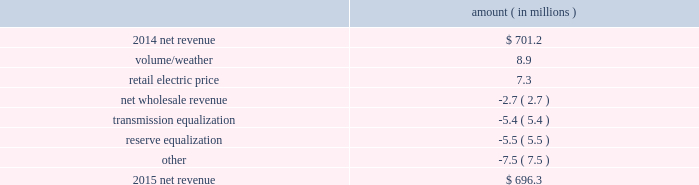Entergy mississippi , inc .
Management 2019s financial discussion and analysis the net wholesale revenue variance is primarily due to entergy mississippi 2019s exit from the system agreement in november 2015 .
The reserve equalization revenue variance is primarily due to the absence of reserve equalization revenue as compared to the same period in 2015 resulting from entergy mississippi 2019s exit from the system agreement in november 2015 compared to 2014 net revenue consists of operating revenues net of : 1 ) fuel , fuel-related expenses , and gas purchased for resale , 2 ) purchased power expenses , and 3 ) other regulatory charges .
Following is an analysis of the change in net revenue comparing 2015 to 2014 .
Amount ( in millions ) .
The volume/weather variance is primarily due to an increase of 86 gwh , or 1% ( 1 % ) , in billed electricity usage , including the effect of more favorable weather on residential and commercial sales .
The retail electric price variance is primarily due to a $ 16 million net annual increase in revenues , effective february 2015 , as a result of the mpsc order in the june 2014 rate case and an increase in revenues collected through the energy efficiency rider , partially offset by a decrease in revenues collected through the storm damage rider .
The rate case included the realignment of certain costs from collection in riders to base rates .
See note 2 to the financial statements for a discussion of the rate case , the energy efficiency rider , and the storm damage rider .
The net wholesale revenue variance is primarily due to a wholesale customer contract termination in october transmission equalization revenue represents amounts received by entergy mississippi from certain other entergy utility operating companies , in accordance with the system agreement , to allocate the costs of collectively planning , constructing , and operating entergy 2019s bulk transmission facilities .
The transmission equalization variance is primarily attributable to the realignment , effective february 2015 , of these revenues from the determination of base rates to inclusion in a rider .
Such revenues had a favorable effect on net revenue in 2014 , but minimal effect in 2015 .
Entergy mississippi exited the system agreement in november 2015 .
See note 2 to the financial statements for a discussion of the system agreement .
Reserve equalization revenue represents amounts received by entergy mississippi from certain other entergy utility operating companies , in accordance with the system agreement , to allocate the costs of collectively maintaining adequate electric generating capacity across the entergy system .
The reserve equalization variance is primarily attributable to the realignment , effective february 2015 , of these revenues from the determination of base rates to inclusion in a rider .
Such revenues had a favorable effect on net revenue in 2014 , but minimal effect in 2015 .
Entergy .
What is the growth rate in net revenue in 2015 for entergy mississippi , inc.? 
Computations: ((696.3 - 701.2) / 701.2)
Answer: -0.00699. 